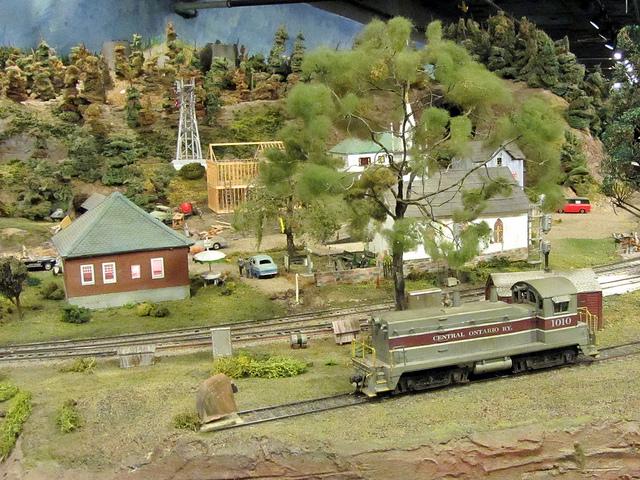Are there lots of trees below this house?
Keep it brief. Yes. Are those things for sale?
Concise answer only. No. Is this an actual landscape?
Write a very short answer. No. What type of building is the train going past?
Quick response, please. Church. Can the engine go further left?
Write a very short answer. Yes. Is the train moving?
Concise answer only. No. Is this an affluent neighborhood?
Quick response, please. No. Is that a real train?
Give a very brief answer. No. 